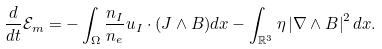Convert formula to latex. <formula><loc_0><loc_0><loc_500><loc_500>\frac { d } { d t } \mathcal { E } _ { m } = - \int _ { \Omega } \frac { n _ { I } } { n _ { e } } u _ { I } \cdot ( J \wedge B ) d x - \int _ { \mathbb { R } ^ { 3 } } \eta \left | \nabla \wedge B \right | ^ { 2 } d x .</formula> 